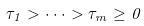Convert formula to latex. <formula><loc_0><loc_0><loc_500><loc_500>\tau _ { 1 } > \cdot \cdot \cdot > \tau _ { m } \geq 0</formula> 